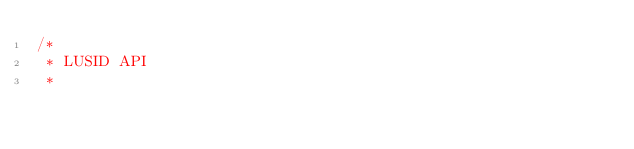Convert code to text. <code><loc_0><loc_0><loc_500><loc_500><_C#_>/* 
 * LUSID API
 *</code> 